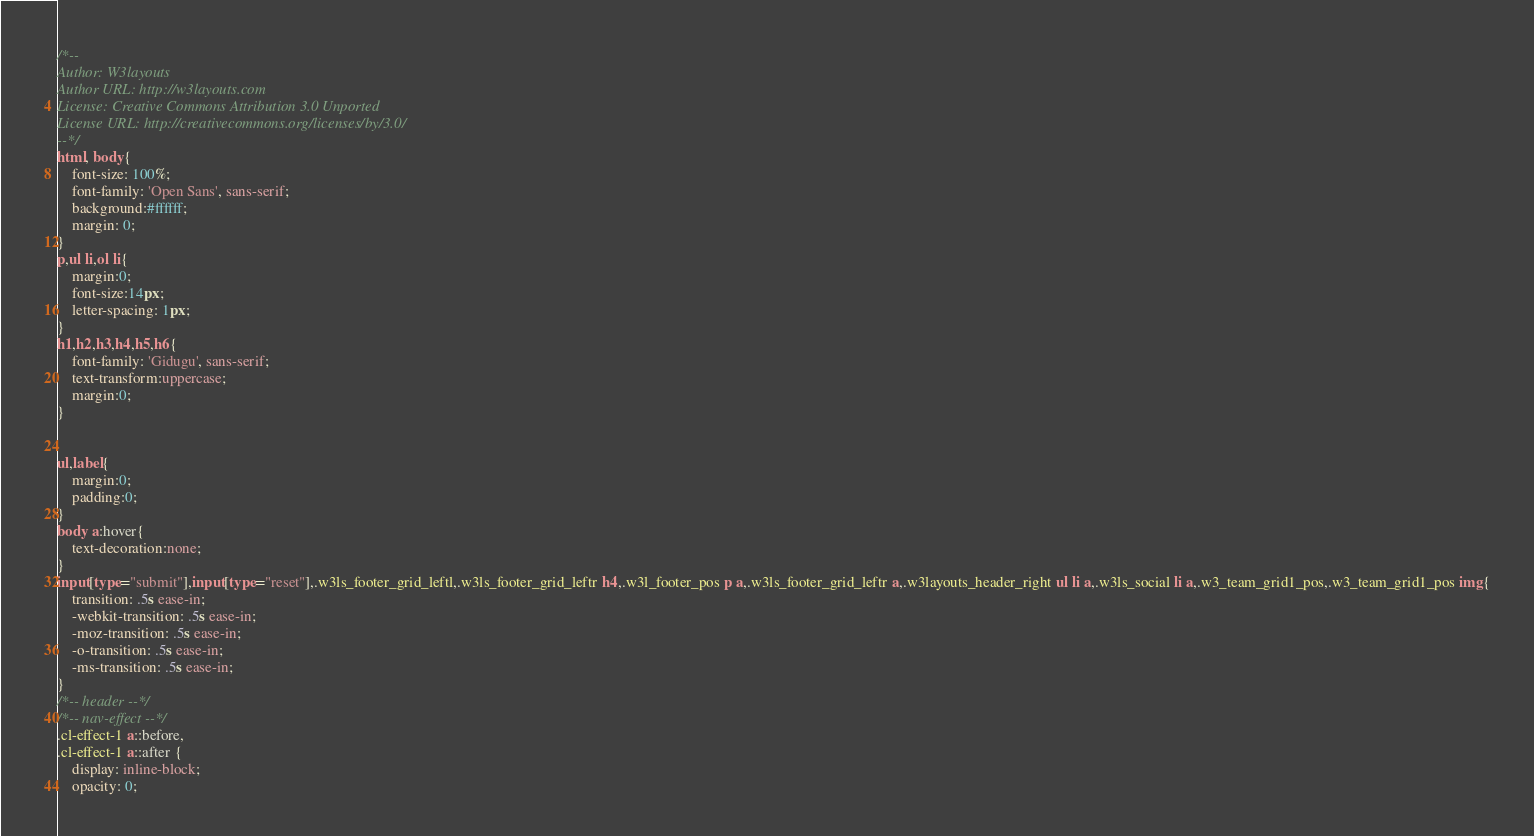Convert code to text. <code><loc_0><loc_0><loc_500><loc_500><_CSS_>/*--
Author: W3layouts
Author URL: http://w3layouts.com
License: Creative Commons Attribution 3.0 Unported
License URL: http://creativecommons.org/licenses/by/3.0/
--*/
html, body{
    font-size: 100%;
	font-family: 'Open Sans', sans-serif;
	background:#ffffff;
	margin: 0;
}
p,ul li,ol li{
	margin:0;
	font-size:14px;
	letter-spacing: 1px;
}
h1,h2,h3,h4,h5,h6{
	font-family: 'Gidugu', sans-serif;
	text-transform:uppercase;
	margin:0;
}


ul,label{
	margin:0;
	padding:0;
}
body a:hover{
	text-decoration:none;
}
input[type="submit"],input[type="reset"],.w3ls_footer_grid_leftl,.w3ls_footer_grid_leftr h4,.w3l_footer_pos p a,.w3ls_footer_grid_leftr a,.w3layouts_header_right ul li a,.w3ls_social li a,.w3_team_grid1_pos,.w3_team_grid1_pos img{
	transition: .5s ease-in;
	-webkit-transition: .5s ease-in;
	-moz-transition: .5s ease-in;
	-o-transition: .5s ease-in;
	-ms-transition: .5s ease-in;
}
/*-- header --*/
/*-- nav-effect --*/
.cl-effect-1 a::before,
.cl-effect-1 a::after {
	display: inline-block;
	opacity: 0;</code> 